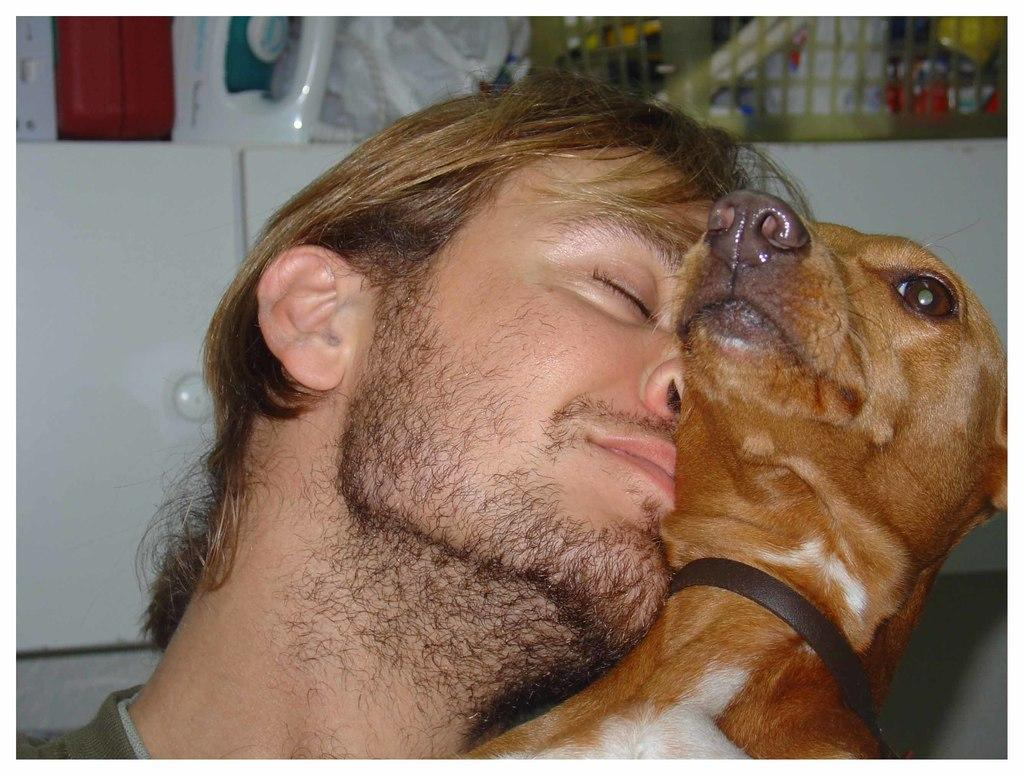Who is present in the image? There is a man in the image. What animal is also present in the image? There is a dog in the image. What object can be seen in the background of the image? There is an iron box in the background of the image. What can be found on a platform in the background of the image? There are objects in a basket on a platform in the background of the image. What type of pan is being used by the man in the image? There is no pan present in the image. 